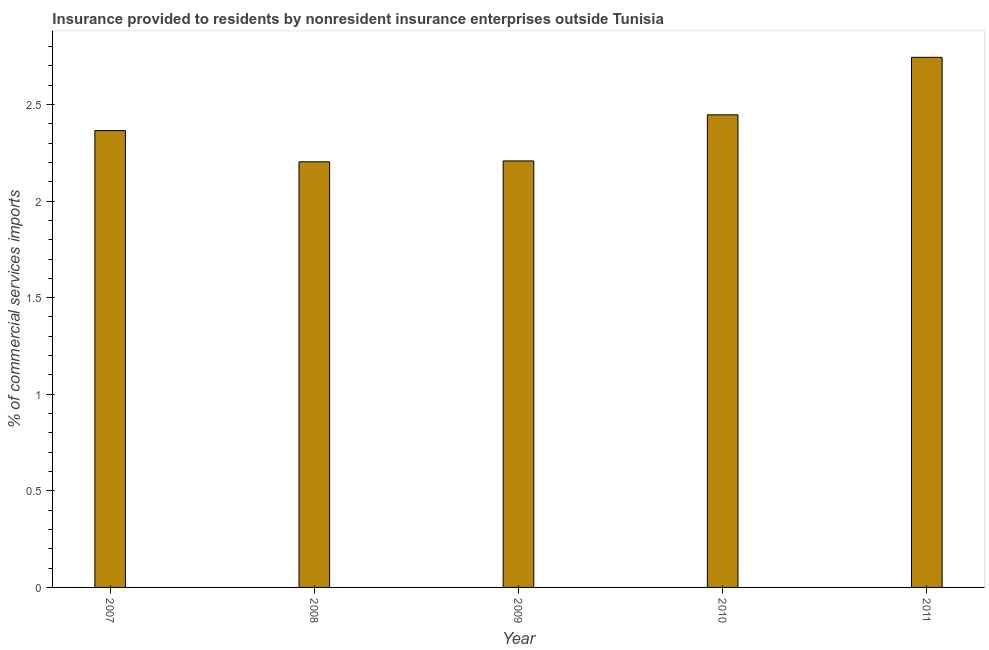Does the graph contain grids?
Your answer should be very brief. No. What is the title of the graph?
Keep it short and to the point. Insurance provided to residents by nonresident insurance enterprises outside Tunisia. What is the label or title of the Y-axis?
Your response must be concise. % of commercial services imports. What is the insurance provided by non-residents in 2008?
Offer a terse response. 2.2. Across all years, what is the maximum insurance provided by non-residents?
Your response must be concise. 2.74. Across all years, what is the minimum insurance provided by non-residents?
Give a very brief answer. 2.2. In which year was the insurance provided by non-residents minimum?
Your answer should be compact. 2008. What is the sum of the insurance provided by non-residents?
Provide a succinct answer. 11.97. What is the difference between the insurance provided by non-residents in 2008 and 2009?
Provide a succinct answer. -0.01. What is the average insurance provided by non-residents per year?
Make the answer very short. 2.39. What is the median insurance provided by non-residents?
Provide a short and direct response. 2.36. Do a majority of the years between 2007 and 2010 (inclusive) have insurance provided by non-residents greater than 0.4 %?
Offer a very short reply. Yes. What is the ratio of the insurance provided by non-residents in 2007 to that in 2008?
Make the answer very short. 1.07. Is the difference between the insurance provided by non-residents in 2009 and 2011 greater than the difference between any two years?
Give a very brief answer. No. What is the difference between the highest and the second highest insurance provided by non-residents?
Offer a terse response. 0.3. Is the sum of the insurance provided by non-residents in 2008 and 2011 greater than the maximum insurance provided by non-residents across all years?
Keep it short and to the point. Yes. What is the difference between the highest and the lowest insurance provided by non-residents?
Offer a terse response. 0.54. In how many years, is the insurance provided by non-residents greater than the average insurance provided by non-residents taken over all years?
Make the answer very short. 2. How many years are there in the graph?
Your answer should be very brief. 5. Are the values on the major ticks of Y-axis written in scientific E-notation?
Ensure brevity in your answer.  No. What is the % of commercial services imports of 2007?
Provide a succinct answer. 2.36. What is the % of commercial services imports in 2008?
Keep it short and to the point. 2.2. What is the % of commercial services imports of 2009?
Offer a very short reply. 2.21. What is the % of commercial services imports of 2010?
Keep it short and to the point. 2.45. What is the % of commercial services imports in 2011?
Keep it short and to the point. 2.74. What is the difference between the % of commercial services imports in 2007 and 2008?
Make the answer very short. 0.16. What is the difference between the % of commercial services imports in 2007 and 2009?
Your answer should be compact. 0.16. What is the difference between the % of commercial services imports in 2007 and 2010?
Give a very brief answer. -0.08. What is the difference between the % of commercial services imports in 2007 and 2011?
Offer a very short reply. -0.38. What is the difference between the % of commercial services imports in 2008 and 2009?
Your answer should be compact. -0. What is the difference between the % of commercial services imports in 2008 and 2010?
Ensure brevity in your answer.  -0.24. What is the difference between the % of commercial services imports in 2008 and 2011?
Provide a short and direct response. -0.54. What is the difference between the % of commercial services imports in 2009 and 2010?
Your answer should be compact. -0.24. What is the difference between the % of commercial services imports in 2009 and 2011?
Provide a succinct answer. -0.54. What is the difference between the % of commercial services imports in 2010 and 2011?
Provide a succinct answer. -0.3. What is the ratio of the % of commercial services imports in 2007 to that in 2008?
Offer a very short reply. 1.07. What is the ratio of the % of commercial services imports in 2007 to that in 2009?
Give a very brief answer. 1.07. What is the ratio of the % of commercial services imports in 2007 to that in 2010?
Your answer should be very brief. 0.97. What is the ratio of the % of commercial services imports in 2007 to that in 2011?
Your answer should be very brief. 0.86. What is the ratio of the % of commercial services imports in 2008 to that in 2010?
Provide a succinct answer. 0.9. What is the ratio of the % of commercial services imports in 2008 to that in 2011?
Provide a succinct answer. 0.8. What is the ratio of the % of commercial services imports in 2009 to that in 2010?
Provide a short and direct response. 0.9. What is the ratio of the % of commercial services imports in 2009 to that in 2011?
Your response must be concise. 0.81. What is the ratio of the % of commercial services imports in 2010 to that in 2011?
Ensure brevity in your answer.  0.89. 